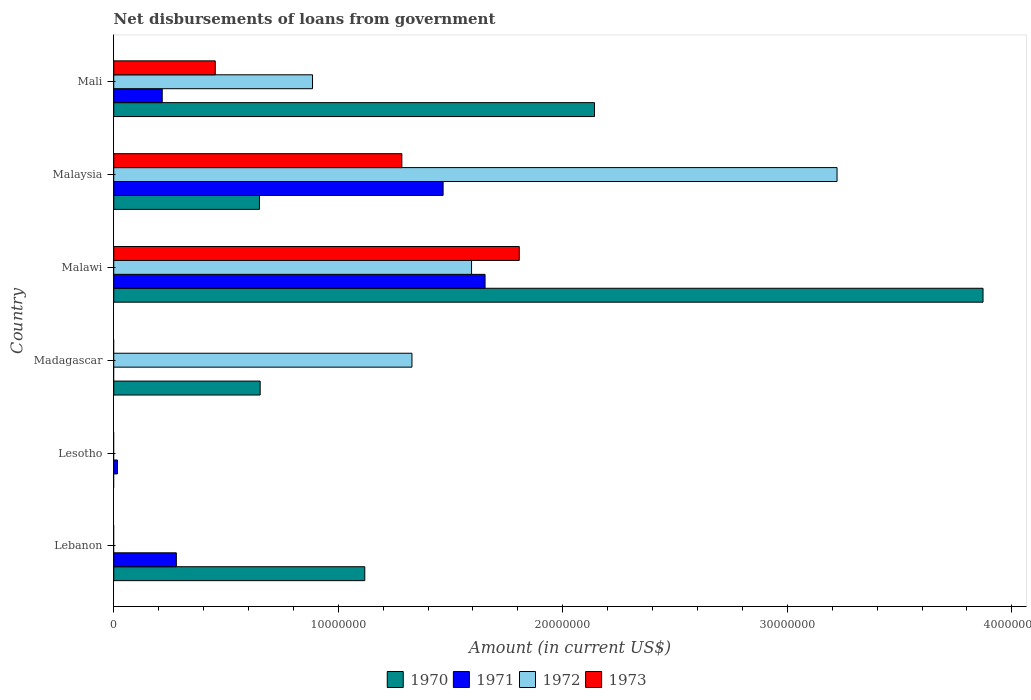Are the number of bars per tick equal to the number of legend labels?
Give a very brief answer. No. How many bars are there on the 2nd tick from the top?
Give a very brief answer. 4. How many bars are there on the 6th tick from the bottom?
Keep it short and to the point. 4. What is the label of the 3rd group of bars from the top?
Give a very brief answer. Malawi. In how many cases, is the number of bars for a given country not equal to the number of legend labels?
Offer a terse response. 3. What is the amount of loan disbursed from government in 1972 in Malawi?
Provide a short and direct response. 1.59e+07. Across all countries, what is the maximum amount of loan disbursed from government in 1971?
Keep it short and to the point. 1.65e+07. In which country was the amount of loan disbursed from government in 1970 maximum?
Your response must be concise. Malawi. What is the total amount of loan disbursed from government in 1973 in the graph?
Make the answer very short. 3.54e+07. What is the difference between the amount of loan disbursed from government in 1971 in Lesotho and that in Malaysia?
Provide a succinct answer. -1.45e+07. What is the difference between the amount of loan disbursed from government in 1972 in Mali and the amount of loan disbursed from government in 1973 in Lebanon?
Provide a short and direct response. 8.85e+06. What is the average amount of loan disbursed from government in 1972 per country?
Your answer should be compact. 1.17e+07. What is the difference between the amount of loan disbursed from government in 1971 and amount of loan disbursed from government in 1970 in Lebanon?
Provide a short and direct response. -8.39e+06. What is the ratio of the amount of loan disbursed from government in 1971 in Lesotho to that in Mali?
Your answer should be very brief. 0.08. Is the amount of loan disbursed from government in 1972 in Malawi less than that in Malaysia?
Make the answer very short. Yes. Is the difference between the amount of loan disbursed from government in 1971 in Lebanon and Malawi greater than the difference between the amount of loan disbursed from government in 1970 in Lebanon and Malawi?
Your response must be concise. Yes. What is the difference between the highest and the second highest amount of loan disbursed from government in 1973?
Your response must be concise. 5.23e+06. What is the difference between the highest and the lowest amount of loan disbursed from government in 1971?
Your response must be concise. 1.65e+07. Is the sum of the amount of loan disbursed from government in 1970 in Madagascar and Malaysia greater than the maximum amount of loan disbursed from government in 1971 across all countries?
Your answer should be compact. No. Is it the case that in every country, the sum of the amount of loan disbursed from government in 1970 and amount of loan disbursed from government in 1973 is greater than the sum of amount of loan disbursed from government in 1972 and amount of loan disbursed from government in 1971?
Offer a very short reply. No. Is it the case that in every country, the sum of the amount of loan disbursed from government in 1971 and amount of loan disbursed from government in 1972 is greater than the amount of loan disbursed from government in 1970?
Your response must be concise. No. Are all the bars in the graph horizontal?
Make the answer very short. Yes. How many countries are there in the graph?
Your response must be concise. 6. Does the graph contain grids?
Ensure brevity in your answer.  No. How many legend labels are there?
Make the answer very short. 4. What is the title of the graph?
Keep it short and to the point. Net disbursements of loans from government. What is the label or title of the Y-axis?
Your answer should be very brief. Country. What is the Amount (in current US$) in 1970 in Lebanon?
Provide a short and direct response. 1.12e+07. What is the Amount (in current US$) of 1971 in Lebanon?
Your response must be concise. 2.79e+06. What is the Amount (in current US$) of 1972 in Lebanon?
Provide a short and direct response. 0. What is the Amount (in current US$) of 1971 in Lesotho?
Ensure brevity in your answer.  1.65e+05. What is the Amount (in current US$) of 1973 in Lesotho?
Your response must be concise. 0. What is the Amount (in current US$) in 1970 in Madagascar?
Give a very brief answer. 6.52e+06. What is the Amount (in current US$) of 1971 in Madagascar?
Offer a terse response. 0. What is the Amount (in current US$) in 1972 in Madagascar?
Offer a very short reply. 1.33e+07. What is the Amount (in current US$) of 1970 in Malawi?
Ensure brevity in your answer.  3.87e+07. What is the Amount (in current US$) of 1971 in Malawi?
Your answer should be compact. 1.65e+07. What is the Amount (in current US$) of 1972 in Malawi?
Offer a terse response. 1.59e+07. What is the Amount (in current US$) of 1973 in Malawi?
Ensure brevity in your answer.  1.81e+07. What is the Amount (in current US$) in 1970 in Malaysia?
Keep it short and to the point. 6.49e+06. What is the Amount (in current US$) in 1971 in Malaysia?
Give a very brief answer. 1.47e+07. What is the Amount (in current US$) in 1972 in Malaysia?
Provide a short and direct response. 3.22e+07. What is the Amount (in current US$) of 1973 in Malaysia?
Your answer should be compact. 1.28e+07. What is the Amount (in current US$) of 1970 in Mali?
Provide a short and direct response. 2.14e+07. What is the Amount (in current US$) of 1971 in Mali?
Your response must be concise. 2.16e+06. What is the Amount (in current US$) of 1972 in Mali?
Give a very brief answer. 8.85e+06. What is the Amount (in current US$) in 1973 in Mali?
Offer a very short reply. 4.52e+06. Across all countries, what is the maximum Amount (in current US$) of 1970?
Your answer should be compact. 3.87e+07. Across all countries, what is the maximum Amount (in current US$) of 1971?
Your answer should be very brief. 1.65e+07. Across all countries, what is the maximum Amount (in current US$) of 1972?
Your response must be concise. 3.22e+07. Across all countries, what is the maximum Amount (in current US$) in 1973?
Give a very brief answer. 1.81e+07. Across all countries, what is the minimum Amount (in current US$) of 1973?
Your answer should be very brief. 0. What is the total Amount (in current US$) in 1970 in the graph?
Your answer should be very brief. 8.43e+07. What is the total Amount (in current US$) of 1971 in the graph?
Your answer should be very brief. 3.63e+07. What is the total Amount (in current US$) of 1972 in the graph?
Keep it short and to the point. 7.03e+07. What is the total Amount (in current US$) of 1973 in the graph?
Offer a terse response. 3.54e+07. What is the difference between the Amount (in current US$) in 1971 in Lebanon and that in Lesotho?
Make the answer very short. 2.62e+06. What is the difference between the Amount (in current US$) of 1970 in Lebanon and that in Madagascar?
Provide a short and direct response. 4.66e+06. What is the difference between the Amount (in current US$) of 1970 in Lebanon and that in Malawi?
Keep it short and to the point. -2.75e+07. What is the difference between the Amount (in current US$) of 1971 in Lebanon and that in Malawi?
Provide a short and direct response. -1.37e+07. What is the difference between the Amount (in current US$) of 1970 in Lebanon and that in Malaysia?
Your response must be concise. 4.69e+06. What is the difference between the Amount (in current US$) of 1971 in Lebanon and that in Malaysia?
Keep it short and to the point. -1.19e+07. What is the difference between the Amount (in current US$) in 1970 in Lebanon and that in Mali?
Provide a short and direct response. -1.02e+07. What is the difference between the Amount (in current US$) of 1971 in Lebanon and that in Mali?
Offer a very short reply. 6.30e+05. What is the difference between the Amount (in current US$) in 1971 in Lesotho and that in Malawi?
Keep it short and to the point. -1.64e+07. What is the difference between the Amount (in current US$) of 1971 in Lesotho and that in Malaysia?
Offer a very short reply. -1.45e+07. What is the difference between the Amount (in current US$) of 1971 in Lesotho and that in Mali?
Provide a short and direct response. -1.99e+06. What is the difference between the Amount (in current US$) in 1970 in Madagascar and that in Malawi?
Offer a very short reply. -3.22e+07. What is the difference between the Amount (in current US$) in 1972 in Madagascar and that in Malawi?
Ensure brevity in your answer.  -2.65e+06. What is the difference between the Amount (in current US$) of 1970 in Madagascar and that in Malaysia?
Keep it short and to the point. 3.20e+04. What is the difference between the Amount (in current US$) in 1972 in Madagascar and that in Malaysia?
Give a very brief answer. -1.89e+07. What is the difference between the Amount (in current US$) of 1970 in Madagascar and that in Mali?
Your response must be concise. -1.49e+07. What is the difference between the Amount (in current US$) of 1972 in Madagascar and that in Mali?
Make the answer very short. 4.43e+06. What is the difference between the Amount (in current US$) of 1970 in Malawi and that in Malaysia?
Make the answer very short. 3.22e+07. What is the difference between the Amount (in current US$) of 1971 in Malawi and that in Malaysia?
Offer a terse response. 1.87e+06. What is the difference between the Amount (in current US$) in 1972 in Malawi and that in Malaysia?
Your answer should be very brief. -1.63e+07. What is the difference between the Amount (in current US$) of 1973 in Malawi and that in Malaysia?
Provide a succinct answer. 5.23e+06. What is the difference between the Amount (in current US$) of 1970 in Malawi and that in Mali?
Keep it short and to the point. 1.73e+07. What is the difference between the Amount (in current US$) of 1971 in Malawi and that in Mali?
Keep it short and to the point. 1.44e+07. What is the difference between the Amount (in current US$) of 1972 in Malawi and that in Mali?
Provide a succinct answer. 7.08e+06. What is the difference between the Amount (in current US$) in 1973 in Malawi and that in Mali?
Give a very brief answer. 1.35e+07. What is the difference between the Amount (in current US$) of 1970 in Malaysia and that in Mali?
Your answer should be compact. -1.49e+07. What is the difference between the Amount (in current US$) of 1971 in Malaysia and that in Mali?
Provide a short and direct response. 1.25e+07. What is the difference between the Amount (in current US$) of 1972 in Malaysia and that in Mali?
Provide a short and direct response. 2.34e+07. What is the difference between the Amount (in current US$) of 1973 in Malaysia and that in Mali?
Give a very brief answer. 8.31e+06. What is the difference between the Amount (in current US$) of 1970 in Lebanon and the Amount (in current US$) of 1971 in Lesotho?
Your response must be concise. 1.10e+07. What is the difference between the Amount (in current US$) of 1970 in Lebanon and the Amount (in current US$) of 1972 in Madagascar?
Provide a short and direct response. -2.10e+06. What is the difference between the Amount (in current US$) of 1971 in Lebanon and the Amount (in current US$) of 1972 in Madagascar?
Offer a very short reply. -1.05e+07. What is the difference between the Amount (in current US$) in 1970 in Lebanon and the Amount (in current US$) in 1971 in Malawi?
Your response must be concise. -5.36e+06. What is the difference between the Amount (in current US$) of 1970 in Lebanon and the Amount (in current US$) of 1972 in Malawi?
Offer a very short reply. -4.76e+06. What is the difference between the Amount (in current US$) of 1970 in Lebanon and the Amount (in current US$) of 1973 in Malawi?
Your answer should be very brief. -6.88e+06. What is the difference between the Amount (in current US$) of 1971 in Lebanon and the Amount (in current US$) of 1972 in Malawi?
Your answer should be compact. -1.31e+07. What is the difference between the Amount (in current US$) of 1971 in Lebanon and the Amount (in current US$) of 1973 in Malawi?
Make the answer very short. -1.53e+07. What is the difference between the Amount (in current US$) of 1970 in Lebanon and the Amount (in current US$) of 1971 in Malaysia?
Keep it short and to the point. -3.49e+06. What is the difference between the Amount (in current US$) in 1970 in Lebanon and the Amount (in current US$) in 1972 in Malaysia?
Your response must be concise. -2.10e+07. What is the difference between the Amount (in current US$) in 1970 in Lebanon and the Amount (in current US$) in 1973 in Malaysia?
Your answer should be compact. -1.65e+06. What is the difference between the Amount (in current US$) in 1971 in Lebanon and the Amount (in current US$) in 1972 in Malaysia?
Make the answer very short. -2.94e+07. What is the difference between the Amount (in current US$) in 1971 in Lebanon and the Amount (in current US$) in 1973 in Malaysia?
Your answer should be compact. -1.00e+07. What is the difference between the Amount (in current US$) in 1970 in Lebanon and the Amount (in current US$) in 1971 in Mali?
Provide a succinct answer. 9.02e+06. What is the difference between the Amount (in current US$) in 1970 in Lebanon and the Amount (in current US$) in 1972 in Mali?
Provide a short and direct response. 2.33e+06. What is the difference between the Amount (in current US$) in 1970 in Lebanon and the Amount (in current US$) in 1973 in Mali?
Offer a terse response. 6.66e+06. What is the difference between the Amount (in current US$) in 1971 in Lebanon and the Amount (in current US$) in 1972 in Mali?
Keep it short and to the point. -6.06e+06. What is the difference between the Amount (in current US$) of 1971 in Lebanon and the Amount (in current US$) of 1973 in Mali?
Provide a succinct answer. -1.73e+06. What is the difference between the Amount (in current US$) of 1971 in Lesotho and the Amount (in current US$) of 1972 in Madagascar?
Your response must be concise. -1.31e+07. What is the difference between the Amount (in current US$) of 1971 in Lesotho and the Amount (in current US$) of 1972 in Malawi?
Your answer should be very brief. -1.58e+07. What is the difference between the Amount (in current US$) of 1971 in Lesotho and the Amount (in current US$) of 1973 in Malawi?
Your response must be concise. -1.79e+07. What is the difference between the Amount (in current US$) of 1971 in Lesotho and the Amount (in current US$) of 1972 in Malaysia?
Give a very brief answer. -3.20e+07. What is the difference between the Amount (in current US$) of 1971 in Lesotho and the Amount (in current US$) of 1973 in Malaysia?
Offer a terse response. -1.27e+07. What is the difference between the Amount (in current US$) in 1971 in Lesotho and the Amount (in current US$) in 1972 in Mali?
Give a very brief answer. -8.69e+06. What is the difference between the Amount (in current US$) of 1971 in Lesotho and the Amount (in current US$) of 1973 in Mali?
Give a very brief answer. -4.36e+06. What is the difference between the Amount (in current US$) of 1970 in Madagascar and the Amount (in current US$) of 1971 in Malawi?
Offer a very short reply. -1.00e+07. What is the difference between the Amount (in current US$) of 1970 in Madagascar and the Amount (in current US$) of 1972 in Malawi?
Give a very brief answer. -9.41e+06. What is the difference between the Amount (in current US$) in 1970 in Madagascar and the Amount (in current US$) in 1973 in Malawi?
Your response must be concise. -1.15e+07. What is the difference between the Amount (in current US$) of 1972 in Madagascar and the Amount (in current US$) of 1973 in Malawi?
Offer a very short reply. -4.78e+06. What is the difference between the Amount (in current US$) in 1970 in Madagascar and the Amount (in current US$) in 1971 in Malaysia?
Provide a succinct answer. -8.15e+06. What is the difference between the Amount (in current US$) in 1970 in Madagascar and the Amount (in current US$) in 1972 in Malaysia?
Provide a short and direct response. -2.57e+07. What is the difference between the Amount (in current US$) in 1970 in Madagascar and the Amount (in current US$) in 1973 in Malaysia?
Your response must be concise. -6.31e+06. What is the difference between the Amount (in current US$) in 1970 in Madagascar and the Amount (in current US$) in 1971 in Mali?
Ensure brevity in your answer.  4.36e+06. What is the difference between the Amount (in current US$) of 1970 in Madagascar and the Amount (in current US$) of 1972 in Mali?
Offer a very short reply. -2.33e+06. What is the difference between the Amount (in current US$) of 1970 in Madagascar and the Amount (in current US$) of 1973 in Mali?
Provide a succinct answer. 2.00e+06. What is the difference between the Amount (in current US$) in 1972 in Madagascar and the Amount (in current US$) in 1973 in Mali?
Your answer should be very brief. 8.76e+06. What is the difference between the Amount (in current US$) in 1970 in Malawi and the Amount (in current US$) in 1971 in Malaysia?
Provide a short and direct response. 2.40e+07. What is the difference between the Amount (in current US$) in 1970 in Malawi and the Amount (in current US$) in 1972 in Malaysia?
Ensure brevity in your answer.  6.50e+06. What is the difference between the Amount (in current US$) of 1970 in Malawi and the Amount (in current US$) of 1973 in Malaysia?
Your answer should be very brief. 2.59e+07. What is the difference between the Amount (in current US$) of 1971 in Malawi and the Amount (in current US$) of 1972 in Malaysia?
Ensure brevity in your answer.  -1.57e+07. What is the difference between the Amount (in current US$) of 1971 in Malawi and the Amount (in current US$) of 1973 in Malaysia?
Offer a terse response. 3.71e+06. What is the difference between the Amount (in current US$) in 1972 in Malawi and the Amount (in current US$) in 1973 in Malaysia?
Give a very brief answer. 3.10e+06. What is the difference between the Amount (in current US$) in 1970 in Malawi and the Amount (in current US$) in 1971 in Mali?
Ensure brevity in your answer.  3.66e+07. What is the difference between the Amount (in current US$) in 1970 in Malawi and the Amount (in current US$) in 1972 in Mali?
Keep it short and to the point. 2.99e+07. What is the difference between the Amount (in current US$) in 1970 in Malawi and the Amount (in current US$) in 1973 in Mali?
Your answer should be very brief. 3.42e+07. What is the difference between the Amount (in current US$) in 1971 in Malawi and the Amount (in current US$) in 1972 in Mali?
Make the answer very short. 7.68e+06. What is the difference between the Amount (in current US$) in 1971 in Malawi and the Amount (in current US$) in 1973 in Mali?
Your response must be concise. 1.20e+07. What is the difference between the Amount (in current US$) in 1972 in Malawi and the Amount (in current US$) in 1973 in Mali?
Offer a very short reply. 1.14e+07. What is the difference between the Amount (in current US$) of 1970 in Malaysia and the Amount (in current US$) of 1971 in Mali?
Your answer should be very brief. 4.33e+06. What is the difference between the Amount (in current US$) of 1970 in Malaysia and the Amount (in current US$) of 1972 in Mali?
Give a very brief answer. -2.36e+06. What is the difference between the Amount (in current US$) of 1970 in Malaysia and the Amount (in current US$) of 1973 in Mali?
Make the answer very short. 1.97e+06. What is the difference between the Amount (in current US$) of 1971 in Malaysia and the Amount (in current US$) of 1972 in Mali?
Your answer should be very brief. 5.82e+06. What is the difference between the Amount (in current US$) in 1971 in Malaysia and the Amount (in current US$) in 1973 in Mali?
Your answer should be very brief. 1.01e+07. What is the difference between the Amount (in current US$) in 1972 in Malaysia and the Amount (in current US$) in 1973 in Mali?
Keep it short and to the point. 2.77e+07. What is the average Amount (in current US$) in 1970 per country?
Keep it short and to the point. 1.41e+07. What is the average Amount (in current US$) in 1971 per country?
Keep it short and to the point. 6.05e+06. What is the average Amount (in current US$) of 1972 per country?
Give a very brief answer. 1.17e+07. What is the average Amount (in current US$) of 1973 per country?
Your answer should be compact. 5.90e+06. What is the difference between the Amount (in current US$) of 1970 and Amount (in current US$) of 1971 in Lebanon?
Give a very brief answer. 8.39e+06. What is the difference between the Amount (in current US$) of 1970 and Amount (in current US$) of 1972 in Madagascar?
Provide a succinct answer. -6.76e+06. What is the difference between the Amount (in current US$) in 1970 and Amount (in current US$) in 1971 in Malawi?
Offer a terse response. 2.22e+07. What is the difference between the Amount (in current US$) of 1970 and Amount (in current US$) of 1972 in Malawi?
Your answer should be very brief. 2.28e+07. What is the difference between the Amount (in current US$) in 1970 and Amount (in current US$) in 1973 in Malawi?
Your answer should be compact. 2.07e+07. What is the difference between the Amount (in current US$) of 1971 and Amount (in current US$) of 1972 in Malawi?
Offer a terse response. 6.02e+05. What is the difference between the Amount (in current US$) in 1971 and Amount (in current US$) in 1973 in Malawi?
Keep it short and to the point. -1.52e+06. What is the difference between the Amount (in current US$) of 1972 and Amount (in current US$) of 1973 in Malawi?
Make the answer very short. -2.12e+06. What is the difference between the Amount (in current US$) of 1970 and Amount (in current US$) of 1971 in Malaysia?
Keep it short and to the point. -8.18e+06. What is the difference between the Amount (in current US$) of 1970 and Amount (in current US$) of 1972 in Malaysia?
Provide a succinct answer. -2.57e+07. What is the difference between the Amount (in current US$) in 1970 and Amount (in current US$) in 1973 in Malaysia?
Provide a succinct answer. -6.34e+06. What is the difference between the Amount (in current US$) of 1971 and Amount (in current US$) of 1972 in Malaysia?
Your answer should be compact. -1.75e+07. What is the difference between the Amount (in current US$) in 1971 and Amount (in current US$) in 1973 in Malaysia?
Your answer should be compact. 1.84e+06. What is the difference between the Amount (in current US$) in 1972 and Amount (in current US$) in 1973 in Malaysia?
Your response must be concise. 1.94e+07. What is the difference between the Amount (in current US$) in 1970 and Amount (in current US$) in 1971 in Mali?
Make the answer very short. 1.93e+07. What is the difference between the Amount (in current US$) in 1970 and Amount (in current US$) in 1972 in Mali?
Make the answer very short. 1.26e+07. What is the difference between the Amount (in current US$) of 1970 and Amount (in current US$) of 1973 in Mali?
Make the answer very short. 1.69e+07. What is the difference between the Amount (in current US$) in 1971 and Amount (in current US$) in 1972 in Mali?
Offer a terse response. -6.70e+06. What is the difference between the Amount (in current US$) of 1971 and Amount (in current US$) of 1973 in Mali?
Your response must be concise. -2.36e+06. What is the difference between the Amount (in current US$) of 1972 and Amount (in current US$) of 1973 in Mali?
Make the answer very short. 4.33e+06. What is the ratio of the Amount (in current US$) in 1971 in Lebanon to that in Lesotho?
Keep it short and to the point. 16.9. What is the ratio of the Amount (in current US$) in 1970 in Lebanon to that in Madagascar?
Your answer should be compact. 1.71. What is the ratio of the Amount (in current US$) of 1970 in Lebanon to that in Malawi?
Provide a short and direct response. 0.29. What is the ratio of the Amount (in current US$) of 1971 in Lebanon to that in Malawi?
Offer a very short reply. 0.17. What is the ratio of the Amount (in current US$) in 1970 in Lebanon to that in Malaysia?
Keep it short and to the point. 1.72. What is the ratio of the Amount (in current US$) in 1971 in Lebanon to that in Malaysia?
Your response must be concise. 0.19. What is the ratio of the Amount (in current US$) in 1970 in Lebanon to that in Mali?
Offer a terse response. 0.52. What is the ratio of the Amount (in current US$) in 1971 in Lebanon to that in Mali?
Your response must be concise. 1.29. What is the ratio of the Amount (in current US$) in 1971 in Lesotho to that in Malaysia?
Provide a short and direct response. 0.01. What is the ratio of the Amount (in current US$) of 1971 in Lesotho to that in Mali?
Provide a short and direct response. 0.08. What is the ratio of the Amount (in current US$) of 1970 in Madagascar to that in Malawi?
Offer a very short reply. 0.17. What is the ratio of the Amount (in current US$) of 1972 in Madagascar to that in Malawi?
Your response must be concise. 0.83. What is the ratio of the Amount (in current US$) in 1972 in Madagascar to that in Malaysia?
Your answer should be compact. 0.41. What is the ratio of the Amount (in current US$) of 1970 in Madagascar to that in Mali?
Offer a terse response. 0.3. What is the ratio of the Amount (in current US$) in 1972 in Madagascar to that in Mali?
Provide a succinct answer. 1.5. What is the ratio of the Amount (in current US$) of 1970 in Malawi to that in Malaysia?
Ensure brevity in your answer.  5.97. What is the ratio of the Amount (in current US$) of 1971 in Malawi to that in Malaysia?
Make the answer very short. 1.13. What is the ratio of the Amount (in current US$) in 1972 in Malawi to that in Malaysia?
Your response must be concise. 0.49. What is the ratio of the Amount (in current US$) in 1973 in Malawi to that in Malaysia?
Give a very brief answer. 1.41. What is the ratio of the Amount (in current US$) of 1970 in Malawi to that in Mali?
Offer a very short reply. 1.81. What is the ratio of the Amount (in current US$) of 1971 in Malawi to that in Mali?
Make the answer very short. 7.66. What is the ratio of the Amount (in current US$) in 1972 in Malawi to that in Mali?
Make the answer very short. 1.8. What is the ratio of the Amount (in current US$) in 1973 in Malawi to that in Mali?
Keep it short and to the point. 3.99. What is the ratio of the Amount (in current US$) in 1970 in Malaysia to that in Mali?
Give a very brief answer. 0.3. What is the ratio of the Amount (in current US$) of 1971 in Malaysia to that in Mali?
Offer a very short reply. 6.79. What is the ratio of the Amount (in current US$) in 1972 in Malaysia to that in Mali?
Your answer should be very brief. 3.64. What is the ratio of the Amount (in current US$) of 1973 in Malaysia to that in Mali?
Keep it short and to the point. 2.84. What is the difference between the highest and the second highest Amount (in current US$) in 1970?
Your answer should be very brief. 1.73e+07. What is the difference between the highest and the second highest Amount (in current US$) in 1971?
Your answer should be compact. 1.87e+06. What is the difference between the highest and the second highest Amount (in current US$) of 1972?
Make the answer very short. 1.63e+07. What is the difference between the highest and the second highest Amount (in current US$) in 1973?
Your answer should be very brief. 5.23e+06. What is the difference between the highest and the lowest Amount (in current US$) of 1970?
Ensure brevity in your answer.  3.87e+07. What is the difference between the highest and the lowest Amount (in current US$) in 1971?
Offer a terse response. 1.65e+07. What is the difference between the highest and the lowest Amount (in current US$) of 1972?
Your answer should be very brief. 3.22e+07. What is the difference between the highest and the lowest Amount (in current US$) in 1973?
Provide a short and direct response. 1.81e+07. 